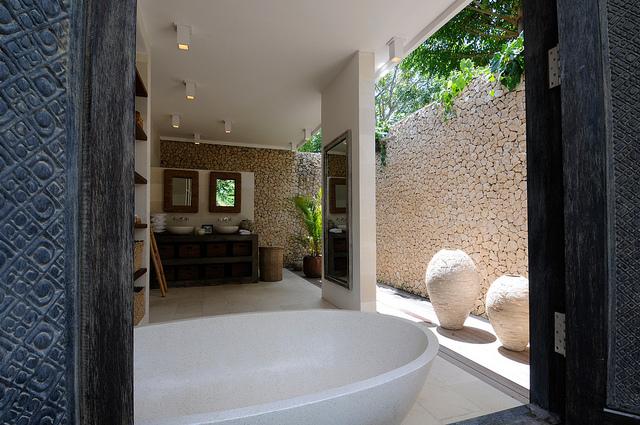What would you call this room?
Be succinct. Bathroom. Is this indoors, or outdoors?
Quick response, please. Indoors. How many mirrors are in this picture?
Quick response, please. 3. 